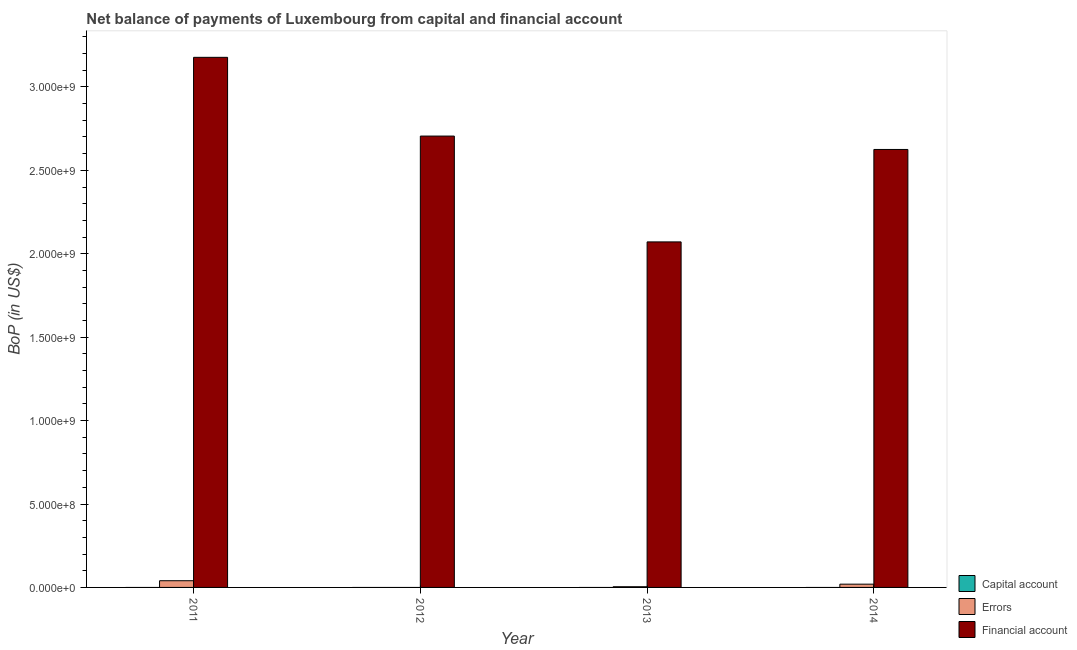How many different coloured bars are there?
Provide a short and direct response. 2. Are the number of bars per tick equal to the number of legend labels?
Provide a short and direct response. No. What is the label of the 3rd group of bars from the left?
Keep it short and to the point. 2013. In how many cases, is the number of bars for a given year not equal to the number of legend labels?
Provide a succinct answer. 4. What is the amount of financial account in 2013?
Offer a very short reply. 2.07e+09. Across all years, what is the maximum amount of financial account?
Ensure brevity in your answer.  3.18e+09. Across all years, what is the minimum amount of errors?
Offer a very short reply. 0. In which year was the amount of financial account maximum?
Your answer should be very brief. 2011. What is the total amount of financial account in the graph?
Keep it short and to the point. 1.06e+1. What is the difference between the amount of financial account in 2012 and that in 2014?
Your response must be concise. 8.02e+07. What is the difference between the amount of financial account in 2014 and the amount of errors in 2012?
Offer a very short reply. -8.02e+07. What is the average amount of financial account per year?
Offer a terse response. 2.64e+09. What is the ratio of the amount of financial account in 2011 to that in 2012?
Ensure brevity in your answer.  1.17. Is the amount of errors in 2011 less than that in 2014?
Make the answer very short. No. What is the difference between the highest and the second highest amount of financial account?
Ensure brevity in your answer.  4.72e+08. What is the difference between the highest and the lowest amount of financial account?
Keep it short and to the point. 1.11e+09. In how many years, is the amount of net capital account greater than the average amount of net capital account taken over all years?
Offer a very short reply. 0. Is the sum of the amount of errors in 2013 and 2014 greater than the maximum amount of financial account across all years?
Keep it short and to the point. No. Is it the case that in every year, the sum of the amount of net capital account and amount of errors is greater than the amount of financial account?
Provide a succinct answer. No. How many bars are there?
Give a very brief answer. 7. Are all the bars in the graph horizontal?
Your answer should be very brief. No. How many years are there in the graph?
Offer a terse response. 4. What is the difference between two consecutive major ticks on the Y-axis?
Provide a succinct answer. 5.00e+08. Are the values on the major ticks of Y-axis written in scientific E-notation?
Your response must be concise. Yes. Where does the legend appear in the graph?
Provide a short and direct response. Bottom right. How many legend labels are there?
Your answer should be very brief. 3. How are the legend labels stacked?
Provide a succinct answer. Vertical. What is the title of the graph?
Make the answer very short. Net balance of payments of Luxembourg from capital and financial account. Does "Self-employed" appear as one of the legend labels in the graph?
Provide a succinct answer. No. What is the label or title of the X-axis?
Give a very brief answer. Year. What is the label or title of the Y-axis?
Your answer should be compact. BoP (in US$). What is the BoP (in US$) in Capital account in 2011?
Give a very brief answer. 0. What is the BoP (in US$) in Errors in 2011?
Keep it short and to the point. 4.02e+07. What is the BoP (in US$) in Financial account in 2011?
Provide a succinct answer. 3.18e+09. What is the BoP (in US$) of Financial account in 2012?
Your answer should be very brief. 2.71e+09. What is the BoP (in US$) of Capital account in 2013?
Provide a short and direct response. 0. What is the BoP (in US$) of Errors in 2013?
Make the answer very short. 4.16e+06. What is the BoP (in US$) in Financial account in 2013?
Offer a terse response. 2.07e+09. What is the BoP (in US$) of Errors in 2014?
Make the answer very short. 1.96e+07. What is the BoP (in US$) of Financial account in 2014?
Offer a terse response. 2.63e+09. Across all years, what is the maximum BoP (in US$) in Errors?
Ensure brevity in your answer.  4.02e+07. Across all years, what is the maximum BoP (in US$) in Financial account?
Your response must be concise. 3.18e+09. Across all years, what is the minimum BoP (in US$) in Financial account?
Ensure brevity in your answer.  2.07e+09. What is the total BoP (in US$) in Capital account in the graph?
Offer a terse response. 0. What is the total BoP (in US$) of Errors in the graph?
Your response must be concise. 6.39e+07. What is the total BoP (in US$) of Financial account in the graph?
Your response must be concise. 1.06e+1. What is the difference between the BoP (in US$) of Financial account in 2011 and that in 2012?
Provide a short and direct response. 4.72e+08. What is the difference between the BoP (in US$) in Errors in 2011 and that in 2013?
Offer a terse response. 3.60e+07. What is the difference between the BoP (in US$) in Financial account in 2011 and that in 2013?
Give a very brief answer. 1.11e+09. What is the difference between the BoP (in US$) in Errors in 2011 and that in 2014?
Your answer should be very brief. 2.06e+07. What is the difference between the BoP (in US$) of Financial account in 2011 and that in 2014?
Your response must be concise. 5.52e+08. What is the difference between the BoP (in US$) of Financial account in 2012 and that in 2013?
Ensure brevity in your answer.  6.34e+08. What is the difference between the BoP (in US$) in Financial account in 2012 and that in 2014?
Make the answer very short. 8.02e+07. What is the difference between the BoP (in US$) of Errors in 2013 and that in 2014?
Your response must be concise. -1.54e+07. What is the difference between the BoP (in US$) of Financial account in 2013 and that in 2014?
Your answer should be very brief. -5.54e+08. What is the difference between the BoP (in US$) in Errors in 2011 and the BoP (in US$) in Financial account in 2012?
Your answer should be very brief. -2.67e+09. What is the difference between the BoP (in US$) in Errors in 2011 and the BoP (in US$) in Financial account in 2013?
Offer a terse response. -2.03e+09. What is the difference between the BoP (in US$) in Errors in 2011 and the BoP (in US$) in Financial account in 2014?
Offer a very short reply. -2.59e+09. What is the difference between the BoP (in US$) in Errors in 2013 and the BoP (in US$) in Financial account in 2014?
Provide a short and direct response. -2.62e+09. What is the average BoP (in US$) in Errors per year?
Your answer should be compact. 1.60e+07. What is the average BoP (in US$) of Financial account per year?
Offer a very short reply. 2.64e+09. In the year 2011, what is the difference between the BoP (in US$) in Errors and BoP (in US$) in Financial account?
Your answer should be compact. -3.14e+09. In the year 2013, what is the difference between the BoP (in US$) in Errors and BoP (in US$) in Financial account?
Offer a terse response. -2.07e+09. In the year 2014, what is the difference between the BoP (in US$) of Errors and BoP (in US$) of Financial account?
Provide a succinct answer. -2.61e+09. What is the ratio of the BoP (in US$) of Financial account in 2011 to that in 2012?
Offer a terse response. 1.17. What is the ratio of the BoP (in US$) of Errors in 2011 to that in 2013?
Give a very brief answer. 9.65. What is the ratio of the BoP (in US$) in Financial account in 2011 to that in 2013?
Offer a terse response. 1.53. What is the ratio of the BoP (in US$) in Errors in 2011 to that in 2014?
Keep it short and to the point. 2.05. What is the ratio of the BoP (in US$) of Financial account in 2011 to that in 2014?
Make the answer very short. 1.21. What is the ratio of the BoP (in US$) of Financial account in 2012 to that in 2013?
Your answer should be compact. 1.31. What is the ratio of the BoP (in US$) in Financial account in 2012 to that in 2014?
Keep it short and to the point. 1.03. What is the ratio of the BoP (in US$) in Errors in 2013 to that in 2014?
Your response must be concise. 0.21. What is the ratio of the BoP (in US$) of Financial account in 2013 to that in 2014?
Keep it short and to the point. 0.79. What is the difference between the highest and the second highest BoP (in US$) in Errors?
Provide a short and direct response. 2.06e+07. What is the difference between the highest and the second highest BoP (in US$) of Financial account?
Offer a very short reply. 4.72e+08. What is the difference between the highest and the lowest BoP (in US$) in Errors?
Your answer should be very brief. 4.02e+07. What is the difference between the highest and the lowest BoP (in US$) in Financial account?
Provide a short and direct response. 1.11e+09. 